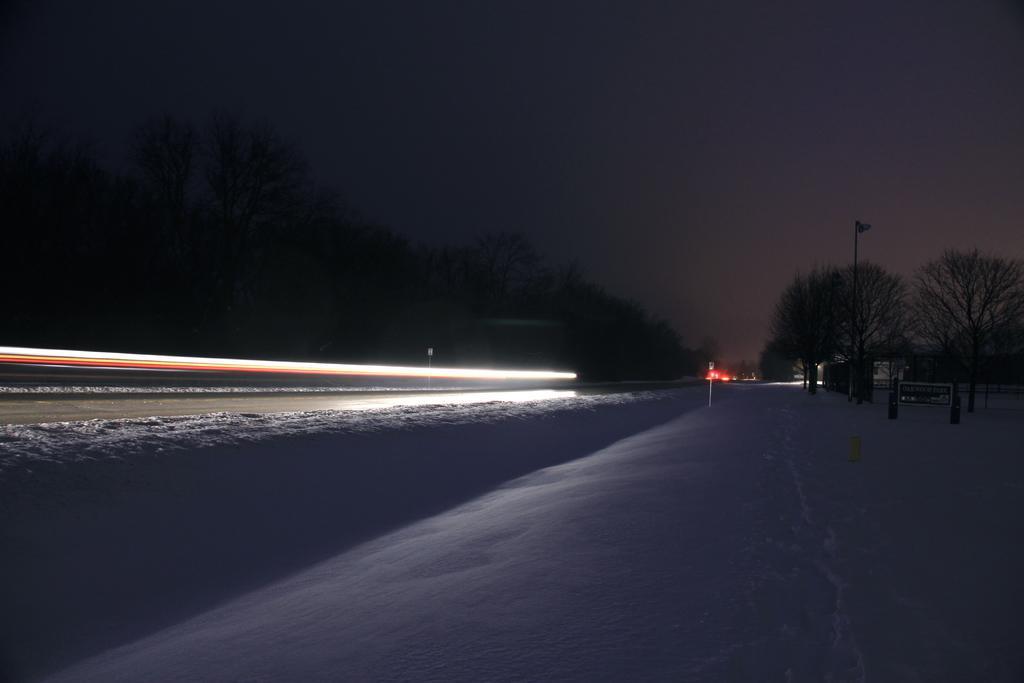Can you describe this image briefly? This image is taken outdoors. At the top of the image there is the sky. At the bottom of the image there is snow on the ground. In the background there are many trees with leaves, stems and branches. There are few poles. There are two boards with text on them. On the left side of the image there is a light. 